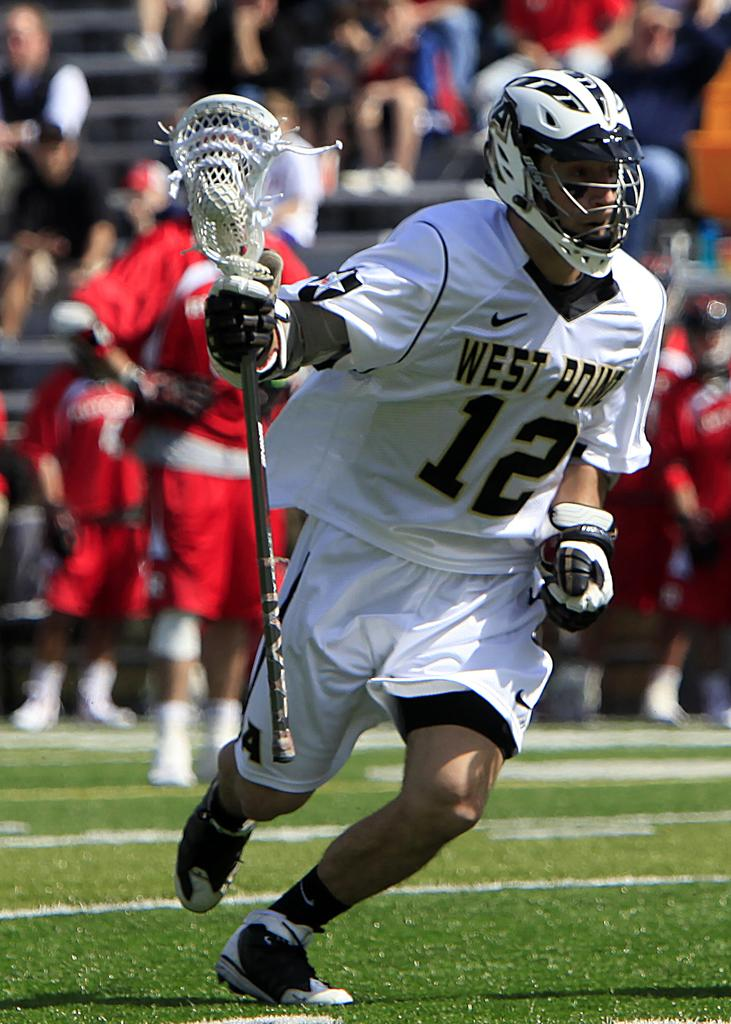What is the person in the image holding? The person in the image is holding a bat. What can be observed about the background of the image? The background of the image is blurred. What else can be seen in the background of the image? There are people and an audience in the background of the image. What is visible in the foreground of the image? There is grass in the foreground of the image. What type of car can be seen in the image? There is no car present in the image. What kind of knife is being used by the person holding the bat? There is no knife visible in the image; the person is only holding a bat. 